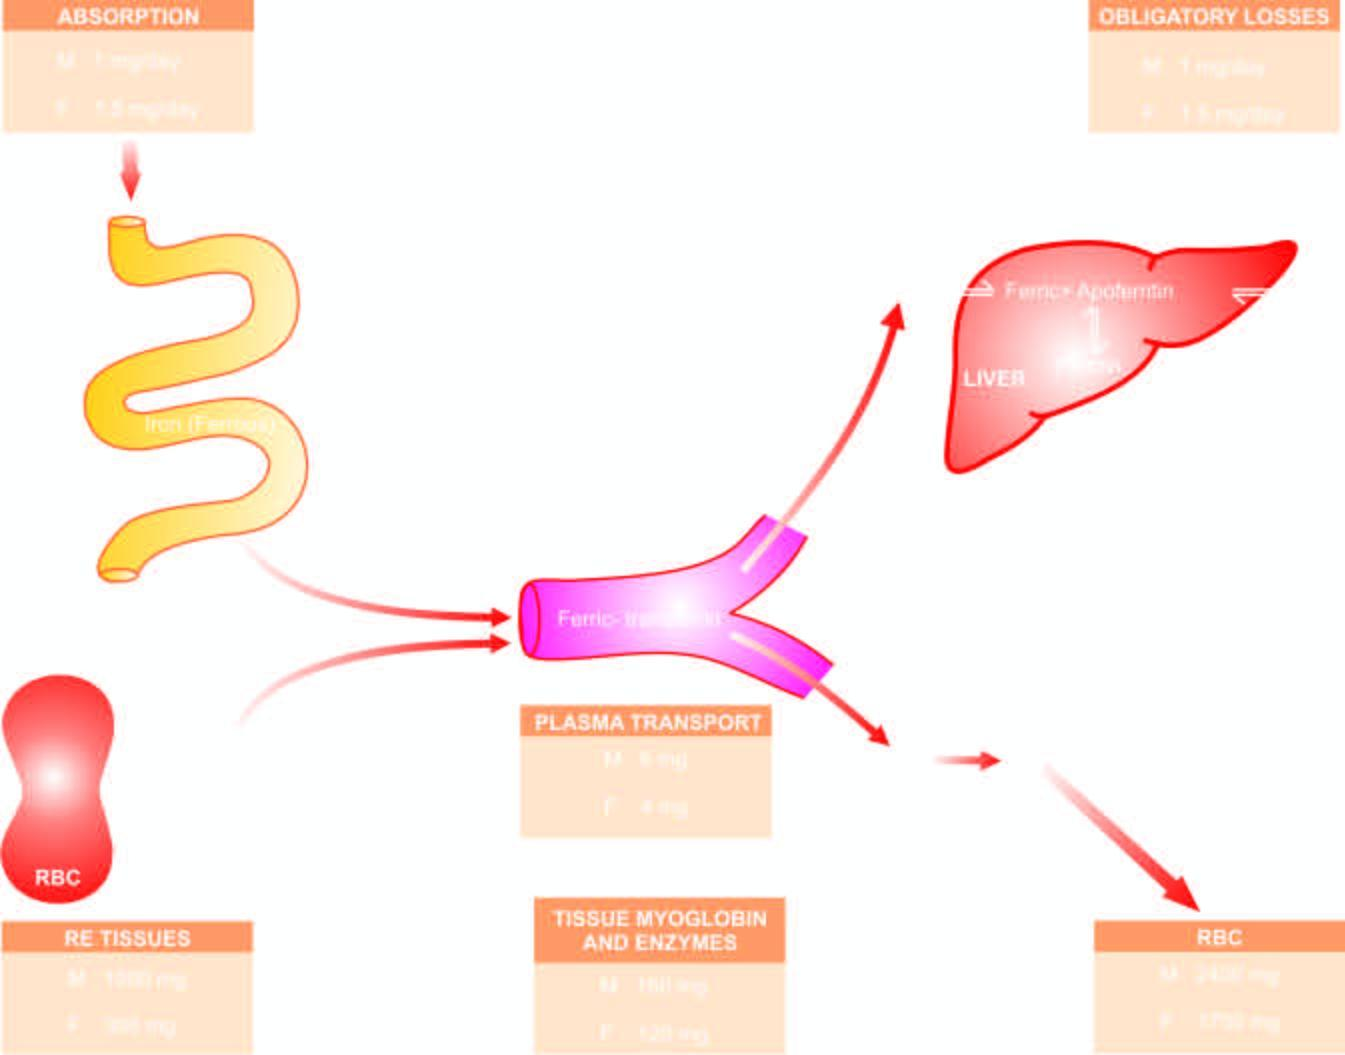s the affected area on right stored as ferritin and haemosiderin?
Answer the question using a single word or phrase. No 